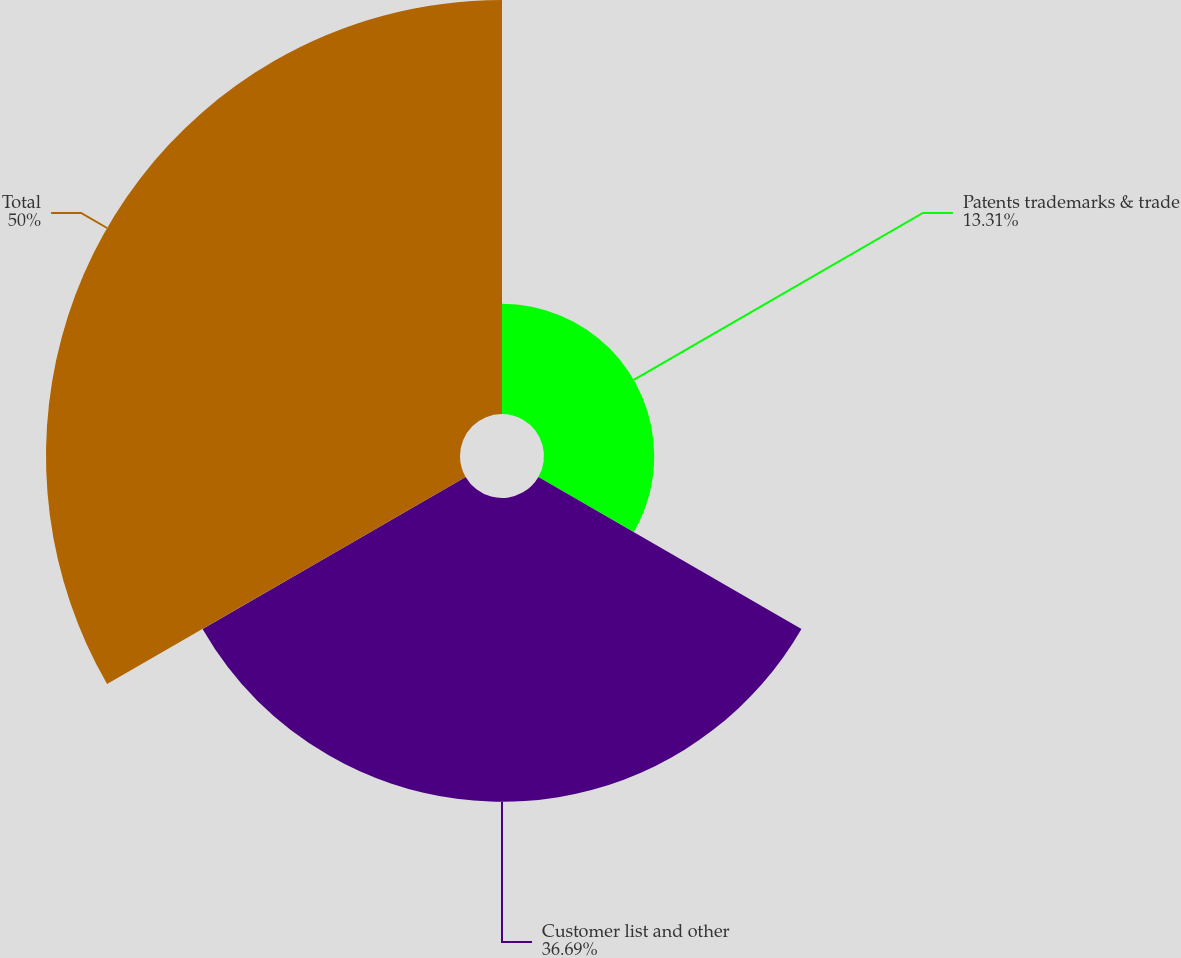Convert chart to OTSL. <chart><loc_0><loc_0><loc_500><loc_500><pie_chart><fcel>Patents trademarks & trade<fcel>Customer list and other<fcel>Total<nl><fcel>13.31%<fcel>36.69%<fcel>50.0%<nl></chart> 